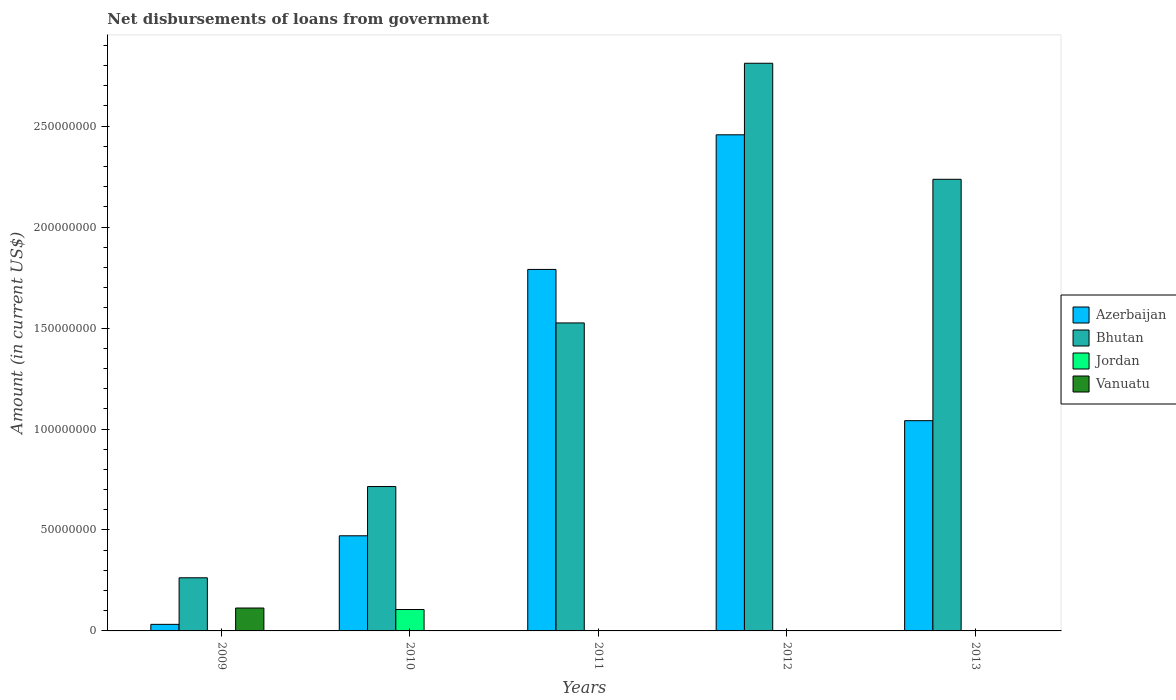Are the number of bars per tick equal to the number of legend labels?
Ensure brevity in your answer.  No. Are the number of bars on each tick of the X-axis equal?
Make the answer very short. No. How many bars are there on the 5th tick from the left?
Your answer should be very brief. 2. What is the label of the 5th group of bars from the left?
Your response must be concise. 2013. What is the amount of loan disbursed from government in Vanuatu in 2009?
Your answer should be very brief. 1.13e+07. Across all years, what is the maximum amount of loan disbursed from government in Bhutan?
Your answer should be very brief. 2.81e+08. Across all years, what is the minimum amount of loan disbursed from government in Azerbaijan?
Make the answer very short. 3.25e+06. In which year was the amount of loan disbursed from government in Bhutan maximum?
Offer a very short reply. 2012. What is the total amount of loan disbursed from government in Bhutan in the graph?
Make the answer very short. 7.55e+08. What is the difference between the amount of loan disbursed from government in Bhutan in 2009 and that in 2012?
Provide a succinct answer. -2.55e+08. What is the average amount of loan disbursed from government in Vanuatu per year?
Provide a succinct answer. 2.27e+06. In the year 2009, what is the difference between the amount of loan disbursed from government in Vanuatu and amount of loan disbursed from government in Bhutan?
Your answer should be compact. -1.50e+07. In how many years, is the amount of loan disbursed from government in Bhutan greater than 160000000 US$?
Offer a very short reply. 2. What is the ratio of the amount of loan disbursed from government in Bhutan in 2009 to that in 2012?
Your response must be concise. 0.09. What is the difference between the highest and the second highest amount of loan disbursed from government in Bhutan?
Offer a very short reply. 5.75e+07. What is the difference between the highest and the lowest amount of loan disbursed from government in Bhutan?
Provide a succinct answer. 2.55e+08. Is it the case that in every year, the sum of the amount of loan disbursed from government in Jordan and amount of loan disbursed from government in Bhutan is greater than the sum of amount of loan disbursed from government in Vanuatu and amount of loan disbursed from government in Azerbaijan?
Your answer should be compact. No. How many bars are there?
Your answer should be very brief. 12. Are all the bars in the graph horizontal?
Offer a terse response. No. Does the graph contain any zero values?
Your response must be concise. Yes. Does the graph contain grids?
Provide a short and direct response. No. Where does the legend appear in the graph?
Ensure brevity in your answer.  Center right. What is the title of the graph?
Make the answer very short. Net disbursements of loans from government. Does "Morocco" appear as one of the legend labels in the graph?
Give a very brief answer. No. What is the Amount (in current US$) of Azerbaijan in 2009?
Provide a succinct answer. 3.25e+06. What is the Amount (in current US$) of Bhutan in 2009?
Give a very brief answer. 2.63e+07. What is the Amount (in current US$) in Vanuatu in 2009?
Your response must be concise. 1.13e+07. What is the Amount (in current US$) in Azerbaijan in 2010?
Provide a succinct answer. 4.71e+07. What is the Amount (in current US$) in Bhutan in 2010?
Give a very brief answer. 7.15e+07. What is the Amount (in current US$) of Jordan in 2010?
Offer a terse response. 1.06e+07. What is the Amount (in current US$) in Vanuatu in 2010?
Keep it short and to the point. 0. What is the Amount (in current US$) of Azerbaijan in 2011?
Provide a succinct answer. 1.79e+08. What is the Amount (in current US$) of Bhutan in 2011?
Offer a terse response. 1.53e+08. What is the Amount (in current US$) in Vanuatu in 2011?
Offer a terse response. 0. What is the Amount (in current US$) in Azerbaijan in 2012?
Offer a very short reply. 2.46e+08. What is the Amount (in current US$) in Bhutan in 2012?
Offer a terse response. 2.81e+08. What is the Amount (in current US$) of Azerbaijan in 2013?
Provide a succinct answer. 1.04e+08. What is the Amount (in current US$) in Bhutan in 2013?
Ensure brevity in your answer.  2.24e+08. Across all years, what is the maximum Amount (in current US$) of Azerbaijan?
Give a very brief answer. 2.46e+08. Across all years, what is the maximum Amount (in current US$) of Bhutan?
Offer a very short reply. 2.81e+08. Across all years, what is the maximum Amount (in current US$) of Jordan?
Keep it short and to the point. 1.06e+07. Across all years, what is the maximum Amount (in current US$) of Vanuatu?
Keep it short and to the point. 1.13e+07. Across all years, what is the minimum Amount (in current US$) of Azerbaijan?
Give a very brief answer. 3.25e+06. Across all years, what is the minimum Amount (in current US$) in Bhutan?
Provide a succinct answer. 2.63e+07. Across all years, what is the minimum Amount (in current US$) of Jordan?
Your response must be concise. 0. What is the total Amount (in current US$) of Azerbaijan in the graph?
Provide a short and direct response. 5.79e+08. What is the total Amount (in current US$) of Bhutan in the graph?
Keep it short and to the point. 7.55e+08. What is the total Amount (in current US$) of Jordan in the graph?
Provide a succinct answer. 1.06e+07. What is the total Amount (in current US$) in Vanuatu in the graph?
Offer a very short reply. 1.13e+07. What is the difference between the Amount (in current US$) of Azerbaijan in 2009 and that in 2010?
Keep it short and to the point. -4.39e+07. What is the difference between the Amount (in current US$) of Bhutan in 2009 and that in 2010?
Provide a short and direct response. -4.52e+07. What is the difference between the Amount (in current US$) of Azerbaijan in 2009 and that in 2011?
Your answer should be compact. -1.76e+08. What is the difference between the Amount (in current US$) of Bhutan in 2009 and that in 2011?
Your answer should be very brief. -1.26e+08. What is the difference between the Amount (in current US$) in Azerbaijan in 2009 and that in 2012?
Your response must be concise. -2.42e+08. What is the difference between the Amount (in current US$) of Bhutan in 2009 and that in 2012?
Your answer should be very brief. -2.55e+08. What is the difference between the Amount (in current US$) of Azerbaijan in 2009 and that in 2013?
Give a very brief answer. -1.01e+08. What is the difference between the Amount (in current US$) in Bhutan in 2009 and that in 2013?
Make the answer very short. -1.97e+08. What is the difference between the Amount (in current US$) of Azerbaijan in 2010 and that in 2011?
Your answer should be very brief. -1.32e+08. What is the difference between the Amount (in current US$) of Bhutan in 2010 and that in 2011?
Keep it short and to the point. -8.10e+07. What is the difference between the Amount (in current US$) in Azerbaijan in 2010 and that in 2012?
Offer a terse response. -1.99e+08. What is the difference between the Amount (in current US$) of Bhutan in 2010 and that in 2012?
Your response must be concise. -2.10e+08. What is the difference between the Amount (in current US$) in Azerbaijan in 2010 and that in 2013?
Your answer should be compact. -5.70e+07. What is the difference between the Amount (in current US$) in Bhutan in 2010 and that in 2013?
Your answer should be very brief. -1.52e+08. What is the difference between the Amount (in current US$) in Azerbaijan in 2011 and that in 2012?
Provide a succinct answer. -6.67e+07. What is the difference between the Amount (in current US$) of Bhutan in 2011 and that in 2012?
Your answer should be very brief. -1.29e+08. What is the difference between the Amount (in current US$) of Azerbaijan in 2011 and that in 2013?
Offer a terse response. 7.49e+07. What is the difference between the Amount (in current US$) in Bhutan in 2011 and that in 2013?
Offer a terse response. -7.11e+07. What is the difference between the Amount (in current US$) in Azerbaijan in 2012 and that in 2013?
Your response must be concise. 1.42e+08. What is the difference between the Amount (in current US$) of Bhutan in 2012 and that in 2013?
Offer a very short reply. 5.75e+07. What is the difference between the Amount (in current US$) of Azerbaijan in 2009 and the Amount (in current US$) of Bhutan in 2010?
Your answer should be very brief. -6.83e+07. What is the difference between the Amount (in current US$) in Azerbaijan in 2009 and the Amount (in current US$) in Jordan in 2010?
Offer a terse response. -7.34e+06. What is the difference between the Amount (in current US$) of Bhutan in 2009 and the Amount (in current US$) of Jordan in 2010?
Offer a terse response. 1.57e+07. What is the difference between the Amount (in current US$) of Azerbaijan in 2009 and the Amount (in current US$) of Bhutan in 2011?
Your response must be concise. -1.49e+08. What is the difference between the Amount (in current US$) in Azerbaijan in 2009 and the Amount (in current US$) in Bhutan in 2012?
Give a very brief answer. -2.78e+08. What is the difference between the Amount (in current US$) in Azerbaijan in 2009 and the Amount (in current US$) in Bhutan in 2013?
Your answer should be compact. -2.20e+08. What is the difference between the Amount (in current US$) of Azerbaijan in 2010 and the Amount (in current US$) of Bhutan in 2011?
Your response must be concise. -1.05e+08. What is the difference between the Amount (in current US$) in Azerbaijan in 2010 and the Amount (in current US$) in Bhutan in 2012?
Provide a succinct answer. -2.34e+08. What is the difference between the Amount (in current US$) of Azerbaijan in 2010 and the Amount (in current US$) of Bhutan in 2013?
Ensure brevity in your answer.  -1.77e+08. What is the difference between the Amount (in current US$) in Azerbaijan in 2011 and the Amount (in current US$) in Bhutan in 2012?
Provide a short and direct response. -1.02e+08. What is the difference between the Amount (in current US$) in Azerbaijan in 2011 and the Amount (in current US$) in Bhutan in 2013?
Give a very brief answer. -4.46e+07. What is the difference between the Amount (in current US$) in Azerbaijan in 2012 and the Amount (in current US$) in Bhutan in 2013?
Your response must be concise. 2.20e+07. What is the average Amount (in current US$) of Azerbaijan per year?
Provide a succinct answer. 1.16e+08. What is the average Amount (in current US$) in Bhutan per year?
Ensure brevity in your answer.  1.51e+08. What is the average Amount (in current US$) of Jordan per year?
Offer a terse response. 2.12e+06. What is the average Amount (in current US$) of Vanuatu per year?
Ensure brevity in your answer.  2.27e+06. In the year 2009, what is the difference between the Amount (in current US$) in Azerbaijan and Amount (in current US$) in Bhutan?
Offer a terse response. -2.31e+07. In the year 2009, what is the difference between the Amount (in current US$) in Azerbaijan and Amount (in current US$) in Vanuatu?
Provide a short and direct response. -8.09e+06. In the year 2009, what is the difference between the Amount (in current US$) of Bhutan and Amount (in current US$) of Vanuatu?
Make the answer very short. 1.50e+07. In the year 2010, what is the difference between the Amount (in current US$) of Azerbaijan and Amount (in current US$) of Bhutan?
Provide a succinct answer. -2.44e+07. In the year 2010, what is the difference between the Amount (in current US$) in Azerbaijan and Amount (in current US$) in Jordan?
Offer a very short reply. 3.65e+07. In the year 2010, what is the difference between the Amount (in current US$) in Bhutan and Amount (in current US$) in Jordan?
Provide a succinct answer. 6.09e+07. In the year 2011, what is the difference between the Amount (in current US$) in Azerbaijan and Amount (in current US$) in Bhutan?
Provide a short and direct response. 2.65e+07. In the year 2012, what is the difference between the Amount (in current US$) of Azerbaijan and Amount (in current US$) of Bhutan?
Your response must be concise. -3.54e+07. In the year 2013, what is the difference between the Amount (in current US$) in Azerbaijan and Amount (in current US$) in Bhutan?
Offer a terse response. -1.20e+08. What is the ratio of the Amount (in current US$) in Azerbaijan in 2009 to that in 2010?
Offer a terse response. 0.07. What is the ratio of the Amount (in current US$) of Bhutan in 2009 to that in 2010?
Give a very brief answer. 0.37. What is the ratio of the Amount (in current US$) of Azerbaijan in 2009 to that in 2011?
Offer a terse response. 0.02. What is the ratio of the Amount (in current US$) in Bhutan in 2009 to that in 2011?
Your answer should be very brief. 0.17. What is the ratio of the Amount (in current US$) of Azerbaijan in 2009 to that in 2012?
Your answer should be compact. 0.01. What is the ratio of the Amount (in current US$) in Bhutan in 2009 to that in 2012?
Provide a short and direct response. 0.09. What is the ratio of the Amount (in current US$) of Azerbaijan in 2009 to that in 2013?
Give a very brief answer. 0.03. What is the ratio of the Amount (in current US$) of Bhutan in 2009 to that in 2013?
Your answer should be very brief. 0.12. What is the ratio of the Amount (in current US$) of Azerbaijan in 2010 to that in 2011?
Ensure brevity in your answer.  0.26. What is the ratio of the Amount (in current US$) of Bhutan in 2010 to that in 2011?
Your response must be concise. 0.47. What is the ratio of the Amount (in current US$) in Azerbaijan in 2010 to that in 2012?
Offer a very short reply. 0.19. What is the ratio of the Amount (in current US$) in Bhutan in 2010 to that in 2012?
Provide a succinct answer. 0.25. What is the ratio of the Amount (in current US$) of Azerbaijan in 2010 to that in 2013?
Keep it short and to the point. 0.45. What is the ratio of the Amount (in current US$) in Bhutan in 2010 to that in 2013?
Provide a succinct answer. 0.32. What is the ratio of the Amount (in current US$) in Azerbaijan in 2011 to that in 2012?
Your answer should be very brief. 0.73. What is the ratio of the Amount (in current US$) in Bhutan in 2011 to that in 2012?
Your answer should be compact. 0.54. What is the ratio of the Amount (in current US$) of Azerbaijan in 2011 to that in 2013?
Offer a very short reply. 1.72. What is the ratio of the Amount (in current US$) in Bhutan in 2011 to that in 2013?
Ensure brevity in your answer.  0.68. What is the ratio of the Amount (in current US$) in Azerbaijan in 2012 to that in 2013?
Provide a short and direct response. 2.36. What is the ratio of the Amount (in current US$) in Bhutan in 2012 to that in 2013?
Keep it short and to the point. 1.26. What is the difference between the highest and the second highest Amount (in current US$) in Azerbaijan?
Provide a succinct answer. 6.67e+07. What is the difference between the highest and the second highest Amount (in current US$) of Bhutan?
Provide a succinct answer. 5.75e+07. What is the difference between the highest and the lowest Amount (in current US$) in Azerbaijan?
Offer a very short reply. 2.42e+08. What is the difference between the highest and the lowest Amount (in current US$) of Bhutan?
Provide a succinct answer. 2.55e+08. What is the difference between the highest and the lowest Amount (in current US$) of Jordan?
Make the answer very short. 1.06e+07. What is the difference between the highest and the lowest Amount (in current US$) in Vanuatu?
Your response must be concise. 1.13e+07. 